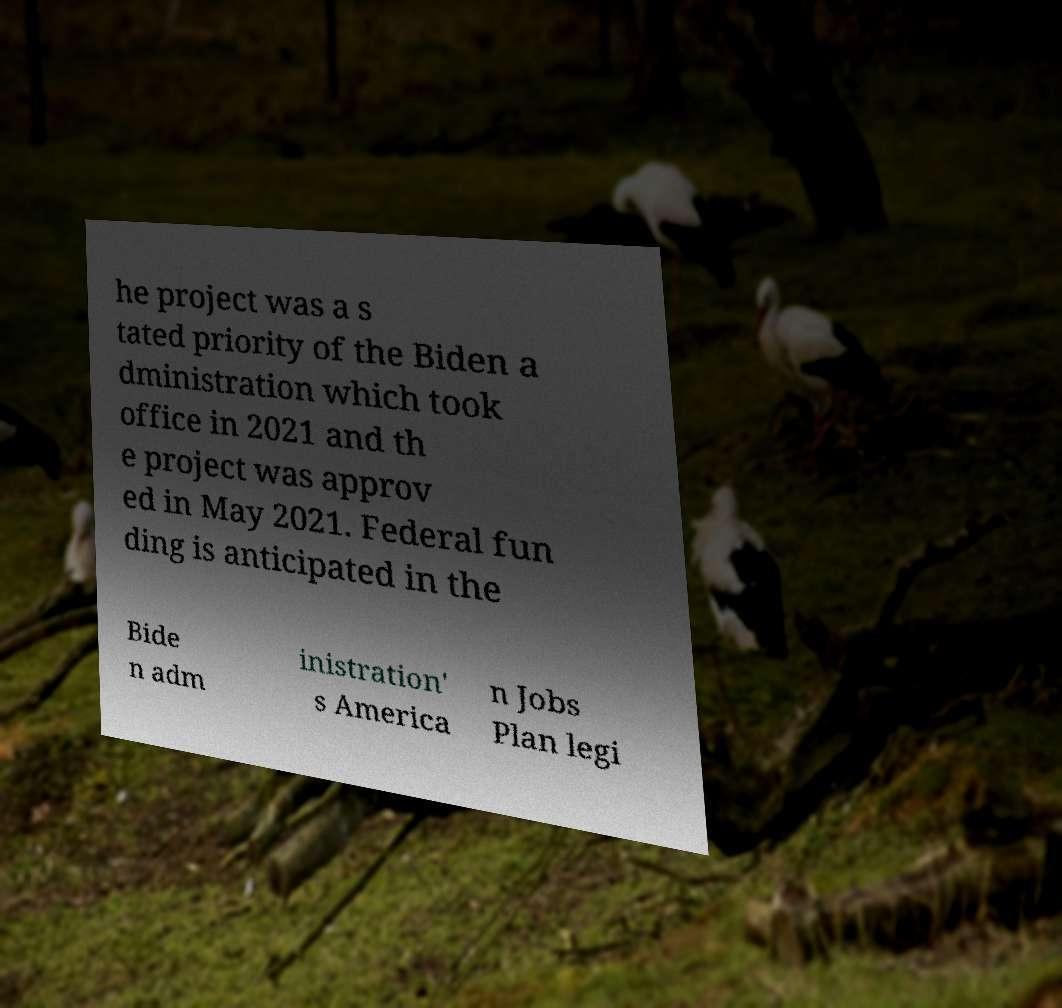There's text embedded in this image that I need extracted. Can you transcribe it verbatim? he project was a s tated priority of the Biden a dministration which took office in 2021 and th e project was approv ed in May 2021. Federal fun ding is anticipated in the Bide n adm inistration' s America n Jobs Plan legi 